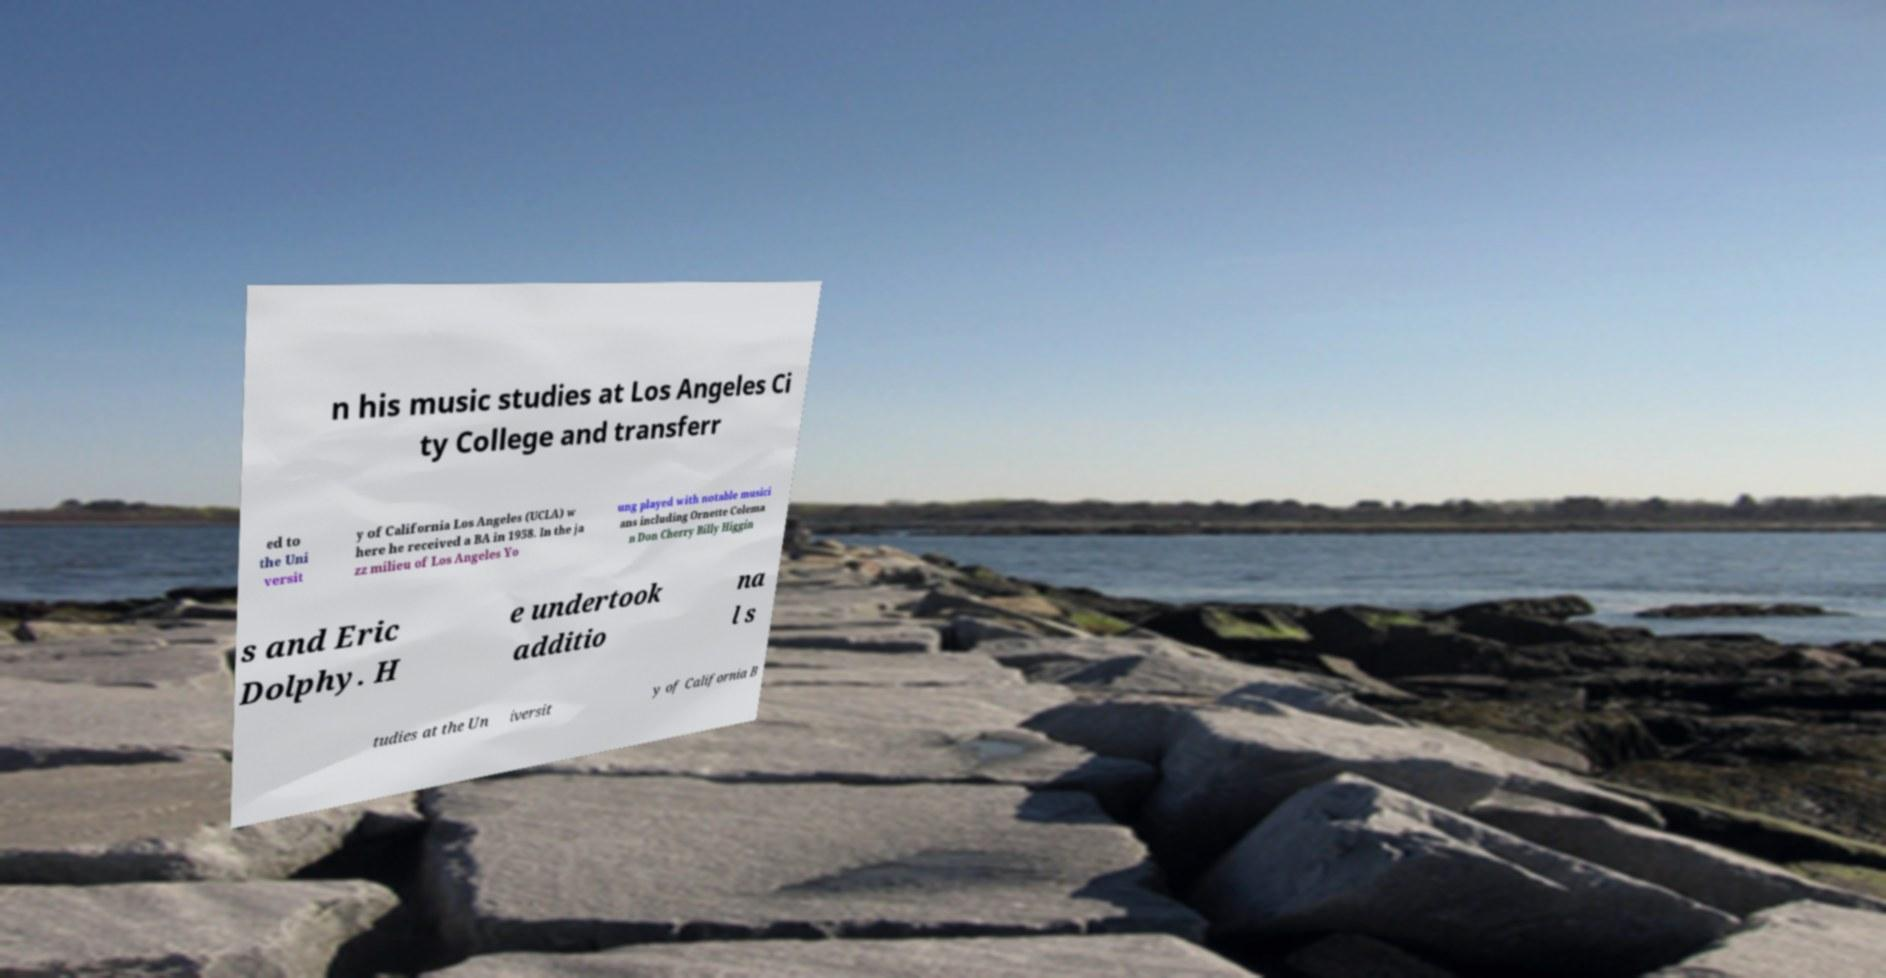Can you accurately transcribe the text from the provided image for me? n his music studies at Los Angeles Ci ty College and transferr ed to the Uni versit y of California Los Angeles (UCLA) w here he received a BA in 1958. In the ja zz milieu of Los Angeles Yo ung played with notable musici ans including Ornette Colema n Don Cherry Billy Higgin s and Eric Dolphy. H e undertook additio na l s tudies at the Un iversit y of California B 